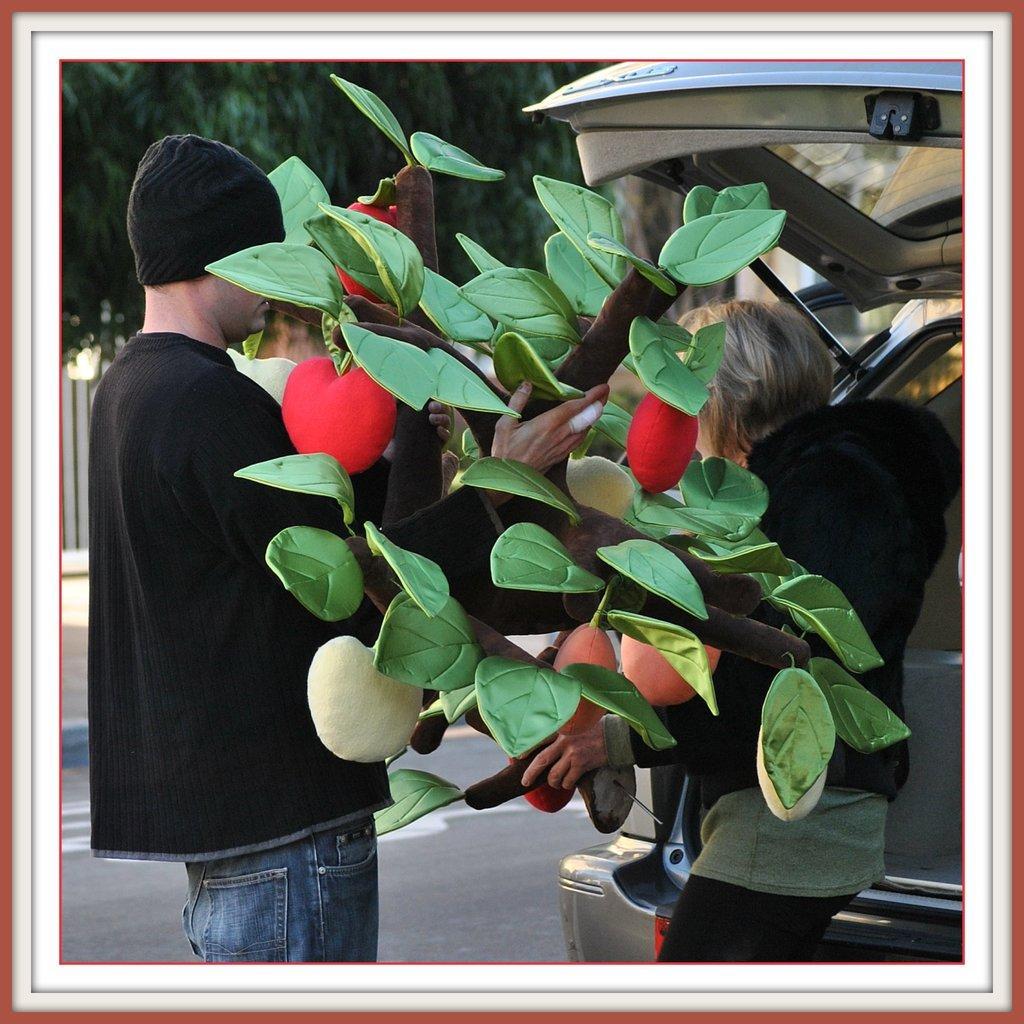Could you give a brief overview of what you see in this image? In this image we can see a man and a woman standing on the ground holding a flower vase. We can also see a car, a fence and a tree. 